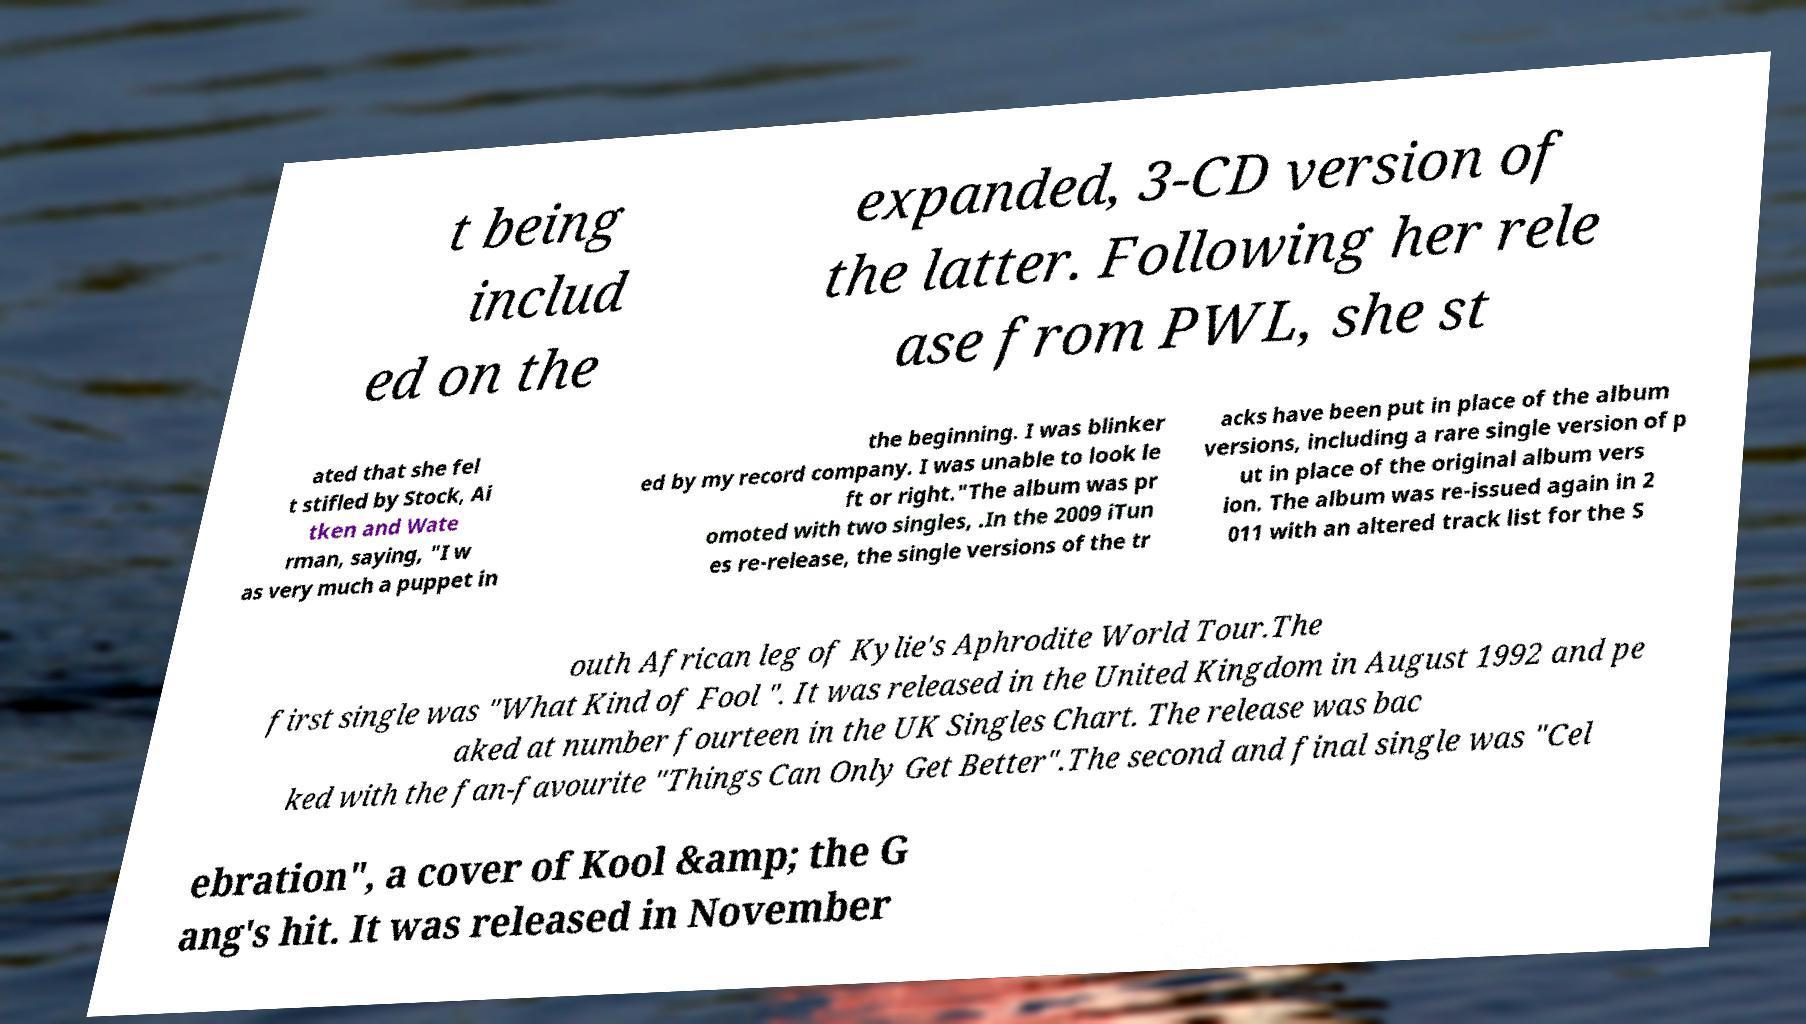Could you extract and type out the text from this image? t being includ ed on the expanded, 3-CD version of the latter. Following her rele ase from PWL, she st ated that she fel t stifled by Stock, Ai tken and Wate rman, saying, "I w as very much a puppet in the beginning. I was blinker ed by my record company. I was unable to look le ft or right."The album was pr omoted with two singles, .In the 2009 iTun es re-release, the single versions of the tr acks have been put in place of the album versions, including a rare single version of p ut in place of the original album vers ion. The album was re-issued again in 2 011 with an altered track list for the S outh African leg of Kylie's Aphrodite World Tour.The first single was "What Kind of Fool ". It was released in the United Kingdom in August 1992 and pe aked at number fourteen in the UK Singles Chart. The release was bac ked with the fan-favourite "Things Can Only Get Better".The second and final single was "Cel ebration", a cover of Kool &amp; the G ang's hit. It was released in November 